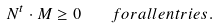Convert formula to latex. <formula><loc_0><loc_0><loc_500><loc_500>N ^ { t } \cdot M \geq 0 \quad f o r a l l e n t r i e s .</formula> 